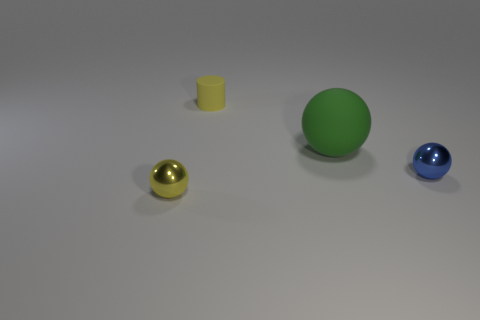Subtract all blue spheres. How many spheres are left? 2 Add 1 small yellow matte cylinders. How many objects exist? 5 Subtract all green spheres. How many spheres are left? 2 Subtract all cylinders. How many objects are left? 3 Subtract all yellow metallic spheres. Subtract all tiny cylinders. How many objects are left? 2 Add 4 tiny cylinders. How many tiny cylinders are left? 5 Add 3 large green spheres. How many large green spheres exist? 4 Subtract 1 green spheres. How many objects are left? 3 Subtract all gray spheres. Subtract all blue cubes. How many spheres are left? 3 Subtract all purple cubes. How many green spheres are left? 1 